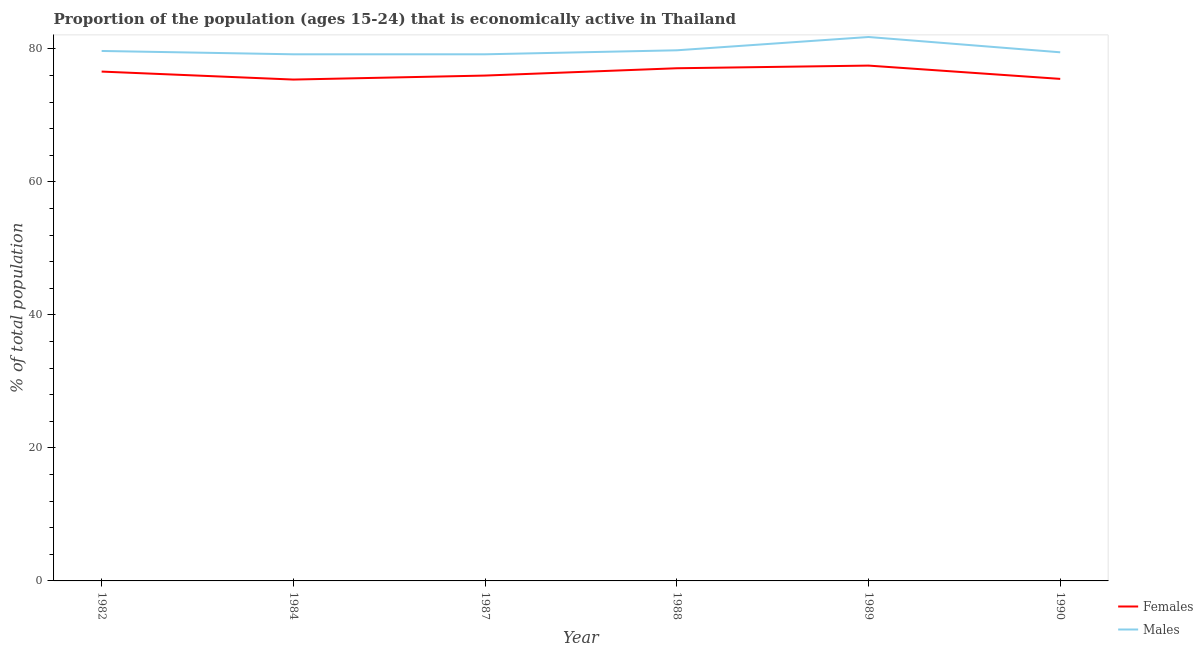What is the percentage of economically active male population in 1990?
Your answer should be compact. 79.5. Across all years, what is the maximum percentage of economically active male population?
Provide a short and direct response. 81.8. Across all years, what is the minimum percentage of economically active female population?
Provide a succinct answer. 75.4. In which year was the percentage of economically active male population minimum?
Your response must be concise. 1984. What is the total percentage of economically active male population in the graph?
Provide a short and direct response. 479.2. What is the difference between the percentage of economically active male population in 1988 and that in 1990?
Offer a terse response. 0.3. What is the difference between the percentage of economically active male population in 1989 and the percentage of economically active female population in 1982?
Provide a short and direct response. 5.2. What is the average percentage of economically active female population per year?
Your answer should be compact. 76.35. In the year 1984, what is the difference between the percentage of economically active male population and percentage of economically active female population?
Provide a succinct answer. 3.8. What is the ratio of the percentage of economically active male population in 1988 to that in 1990?
Ensure brevity in your answer.  1. Is the percentage of economically active female population in 1987 less than that in 1989?
Provide a short and direct response. Yes. Is the difference between the percentage of economically active male population in 1987 and 1989 greater than the difference between the percentage of economically active female population in 1987 and 1989?
Ensure brevity in your answer.  No. What is the difference between the highest and the second highest percentage of economically active female population?
Provide a succinct answer. 0.4. What is the difference between the highest and the lowest percentage of economically active female population?
Make the answer very short. 2.1. Is the percentage of economically active female population strictly greater than the percentage of economically active male population over the years?
Your answer should be compact. No. Is the percentage of economically active female population strictly less than the percentage of economically active male population over the years?
Your answer should be compact. Yes. How many years are there in the graph?
Provide a short and direct response. 6. Does the graph contain grids?
Ensure brevity in your answer.  No. Where does the legend appear in the graph?
Make the answer very short. Bottom right. How many legend labels are there?
Give a very brief answer. 2. How are the legend labels stacked?
Make the answer very short. Vertical. What is the title of the graph?
Make the answer very short. Proportion of the population (ages 15-24) that is economically active in Thailand. What is the label or title of the X-axis?
Ensure brevity in your answer.  Year. What is the label or title of the Y-axis?
Make the answer very short. % of total population. What is the % of total population in Females in 1982?
Your answer should be very brief. 76.6. What is the % of total population of Males in 1982?
Offer a very short reply. 79.7. What is the % of total population in Females in 1984?
Keep it short and to the point. 75.4. What is the % of total population in Males in 1984?
Make the answer very short. 79.2. What is the % of total population of Females in 1987?
Make the answer very short. 76. What is the % of total population of Males in 1987?
Keep it short and to the point. 79.2. What is the % of total population of Females in 1988?
Keep it short and to the point. 77.1. What is the % of total population of Males in 1988?
Offer a very short reply. 79.8. What is the % of total population in Females in 1989?
Your answer should be very brief. 77.5. What is the % of total population in Males in 1989?
Provide a short and direct response. 81.8. What is the % of total population of Females in 1990?
Provide a succinct answer. 75.5. What is the % of total population of Males in 1990?
Offer a terse response. 79.5. Across all years, what is the maximum % of total population of Females?
Your response must be concise. 77.5. Across all years, what is the maximum % of total population of Males?
Your answer should be very brief. 81.8. Across all years, what is the minimum % of total population in Females?
Ensure brevity in your answer.  75.4. Across all years, what is the minimum % of total population of Males?
Provide a short and direct response. 79.2. What is the total % of total population of Females in the graph?
Your answer should be compact. 458.1. What is the total % of total population of Males in the graph?
Offer a terse response. 479.2. What is the difference between the % of total population of Males in 1982 and that in 1984?
Make the answer very short. 0.5. What is the difference between the % of total population in Females in 1982 and that in 1987?
Your response must be concise. 0.6. What is the difference between the % of total population in Males in 1982 and that in 1987?
Your answer should be very brief. 0.5. What is the difference between the % of total population of Females in 1982 and that in 1989?
Your response must be concise. -0.9. What is the difference between the % of total population in Females in 1982 and that in 1990?
Offer a terse response. 1.1. What is the difference between the % of total population of Females in 1984 and that in 1987?
Give a very brief answer. -0.6. What is the difference between the % of total population in Males in 1984 and that in 1987?
Offer a very short reply. 0. What is the difference between the % of total population in Females in 1984 and that in 1988?
Your answer should be compact. -1.7. What is the difference between the % of total population in Females in 1984 and that in 1990?
Your answer should be very brief. -0.1. What is the difference between the % of total population in Males in 1984 and that in 1990?
Offer a very short reply. -0.3. What is the difference between the % of total population of Males in 1987 and that in 1988?
Make the answer very short. -0.6. What is the difference between the % of total population in Females in 1987 and that in 1989?
Provide a short and direct response. -1.5. What is the difference between the % of total population in Males in 1987 and that in 1990?
Give a very brief answer. -0.3. What is the difference between the % of total population of Females in 1988 and that in 1989?
Your response must be concise. -0.4. What is the difference between the % of total population in Females in 1988 and that in 1990?
Ensure brevity in your answer.  1.6. What is the difference between the % of total population in Males in 1988 and that in 1990?
Offer a terse response. 0.3. What is the difference between the % of total population in Females in 1989 and that in 1990?
Your answer should be compact. 2. What is the difference between the % of total population in Males in 1989 and that in 1990?
Ensure brevity in your answer.  2.3. What is the difference between the % of total population in Females in 1982 and the % of total population in Males in 1988?
Give a very brief answer. -3.2. What is the difference between the % of total population of Females in 1982 and the % of total population of Males in 1990?
Offer a terse response. -2.9. What is the difference between the % of total population in Females in 1984 and the % of total population in Males in 1987?
Ensure brevity in your answer.  -3.8. What is the difference between the % of total population of Females in 1984 and the % of total population of Males in 1988?
Keep it short and to the point. -4.4. What is the difference between the % of total population of Females in 1987 and the % of total population of Males in 1988?
Offer a terse response. -3.8. What is the difference between the % of total population of Females in 1987 and the % of total population of Males in 1989?
Your answer should be compact. -5.8. What is the difference between the % of total population of Females in 1988 and the % of total population of Males in 1990?
Offer a terse response. -2.4. What is the average % of total population of Females per year?
Offer a very short reply. 76.35. What is the average % of total population of Males per year?
Make the answer very short. 79.87. In the year 1982, what is the difference between the % of total population in Females and % of total population in Males?
Ensure brevity in your answer.  -3.1. In the year 1984, what is the difference between the % of total population of Females and % of total population of Males?
Provide a succinct answer. -3.8. What is the ratio of the % of total population in Females in 1982 to that in 1984?
Offer a very short reply. 1.02. What is the ratio of the % of total population in Males in 1982 to that in 1984?
Ensure brevity in your answer.  1.01. What is the ratio of the % of total population in Females in 1982 to that in 1987?
Offer a very short reply. 1.01. What is the ratio of the % of total population of Males in 1982 to that in 1987?
Your answer should be compact. 1.01. What is the ratio of the % of total population in Females in 1982 to that in 1988?
Offer a very short reply. 0.99. What is the ratio of the % of total population of Males in 1982 to that in 1988?
Provide a short and direct response. 1. What is the ratio of the % of total population of Females in 1982 to that in 1989?
Your answer should be compact. 0.99. What is the ratio of the % of total population in Males in 1982 to that in 1989?
Your answer should be very brief. 0.97. What is the ratio of the % of total population of Females in 1982 to that in 1990?
Make the answer very short. 1.01. What is the ratio of the % of total population of Females in 1984 to that in 1987?
Offer a terse response. 0.99. What is the ratio of the % of total population in Females in 1984 to that in 1989?
Offer a terse response. 0.97. What is the ratio of the % of total population in Males in 1984 to that in 1989?
Offer a terse response. 0.97. What is the ratio of the % of total population of Females in 1984 to that in 1990?
Provide a succinct answer. 1. What is the ratio of the % of total population in Males in 1984 to that in 1990?
Ensure brevity in your answer.  1. What is the ratio of the % of total population in Females in 1987 to that in 1988?
Your answer should be very brief. 0.99. What is the ratio of the % of total population of Females in 1987 to that in 1989?
Your response must be concise. 0.98. What is the ratio of the % of total population in Males in 1987 to that in 1989?
Ensure brevity in your answer.  0.97. What is the ratio of the % of total population in Females in 1987 to that in 1990?
Give a very brief answer. 1.01. What is the ratio of the % of total population of Males in 1987 to that in 1990?
Your response must be concise. 1. What is the ratio of the % of total population in Males in 1988 to that in 1989?
Give a very brief answer. 0.98. What is the ratio of the % of total population in Females in 1988 to that in 1990?
Keep it short and to the point. 1.02. What is the ratio of the % of total population of Females in 1989 to that in 1990?
Your answer should be compact. 1.03. What is the ratio of the % of total population of Males in 1989 to that in 1990?
Keep it short and to the point. 1.03. What is the difference between the highest and the second highest % of total population in Females?
Provide a short and direct response. 0.4. What is the difference between the highest and the second highest % of total population of Males?
Offer a terse response. 2. 